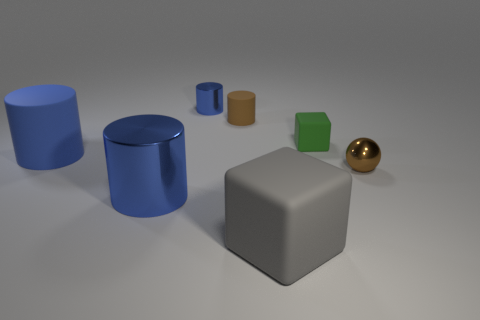Subtract all blue cylinders. How many were subtracted if there are1blue cylinders left? 2 Subtract all gray cubes. How many blue cylinders are left? 3 Subtract all brown cylinders. How many cylinders are left? 3 Add 2 tiny brown matte things. How many objects exist? 9 Subtract all yellow cylinders. Subtract all purple balls. How many cylinders are left? 4 Subtract all cylinders. How many objects are left? 3 Add 5 small matte cylinders. How many small matte cylinders exist? 6 Subtract 0 gray cylinders. How many objects are left? 7 Subtract all large gray matte objects. Subtract all large rubber cubes. How many objects are left? 5 Add 7 small blue metal things. How many small blue metal things are left? 8 